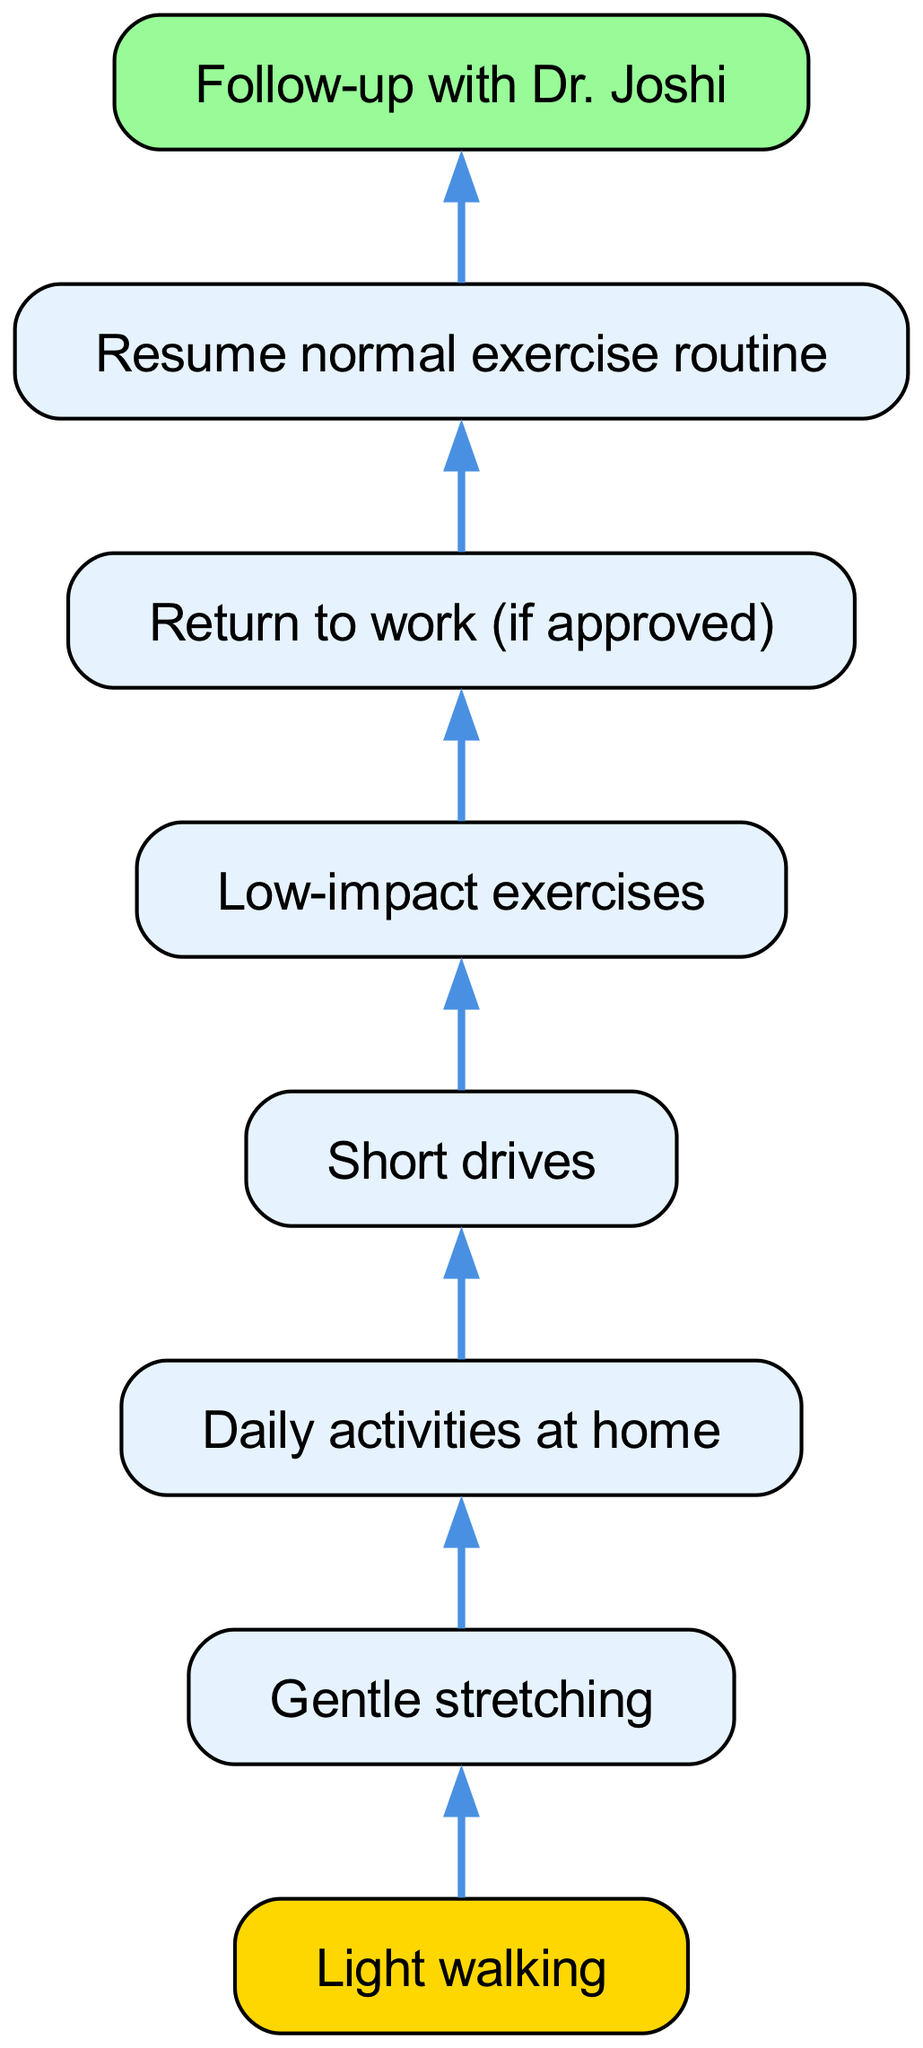What is the first activity listed in the diagram? The first activity, as represented in the diagram, is "Light walking," which is the top node in the bottom-up flow.
Answer: Light walking How many activities are there in the diagram? By counting all the distinct nodes in the diagram, we find there are eight activities listed.
Answer: 8 What is the last activity before the follow-up with Dr. Joshi? The activity immediately preceding the follow-up is "Resume normal exercise routine," which is the second-to-last node in the flow.
Answer: Resume normal exercise routine Which activity is a prerequisite for returning to work? The prerequisite activity for returning to work, as per the diagram's flow, is "Low-impact exercises," which must be completed before moving on to the next step.
Answer: Low-impact exercises If you complete "Daily activities at home," what is the next activity you will engage in? After completing "Daily activities at home," the subsequent activity depicted in the diagram is "Short drives."
Answer: Short drives What two activities follow "Gentle stretching"? The activities that follow "Gentle stretching" are "Daily activities at home" and subsequently "Short drives," which are sequential steps shown in the diagram.
Answer: Daily activities at home, Short drives Does "Light walking" lead to any other activity directly? Yes, "Light walking" leads directly to "Gentle stretching," which is the next step according to the flow.
Answer: Gentle stretching Which activity is necessary to perform before any exercise routines? The necessary activity before any exercise routines is "Low-impact exercises," as indicated in the flow leading to resuming normal routines.
Answer: Low-impact exercises How does the flow chart structure imply progression in activities? The flow chart is structured in a bottom-up manner, where each activity feeds into the next, indicating that completion of underlying activities is essential before advancing to more strenuous actions.
Answer: Through a sequential structure 